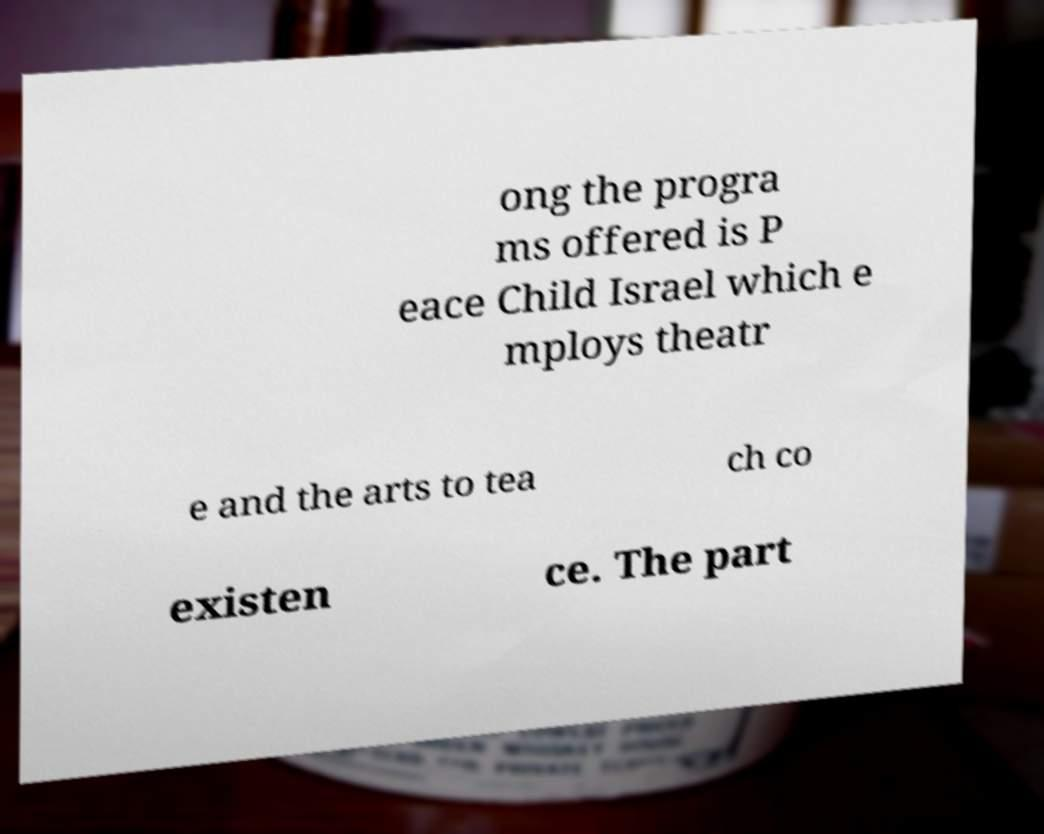Can you read and provide the text displayed in the image?This photo seems to have some interesting text. Can you extract and type it out for me? ong the progra ms offered is P eace Child Israel which e mploys theatr e and the arts to tea ch co existen ce. The part 